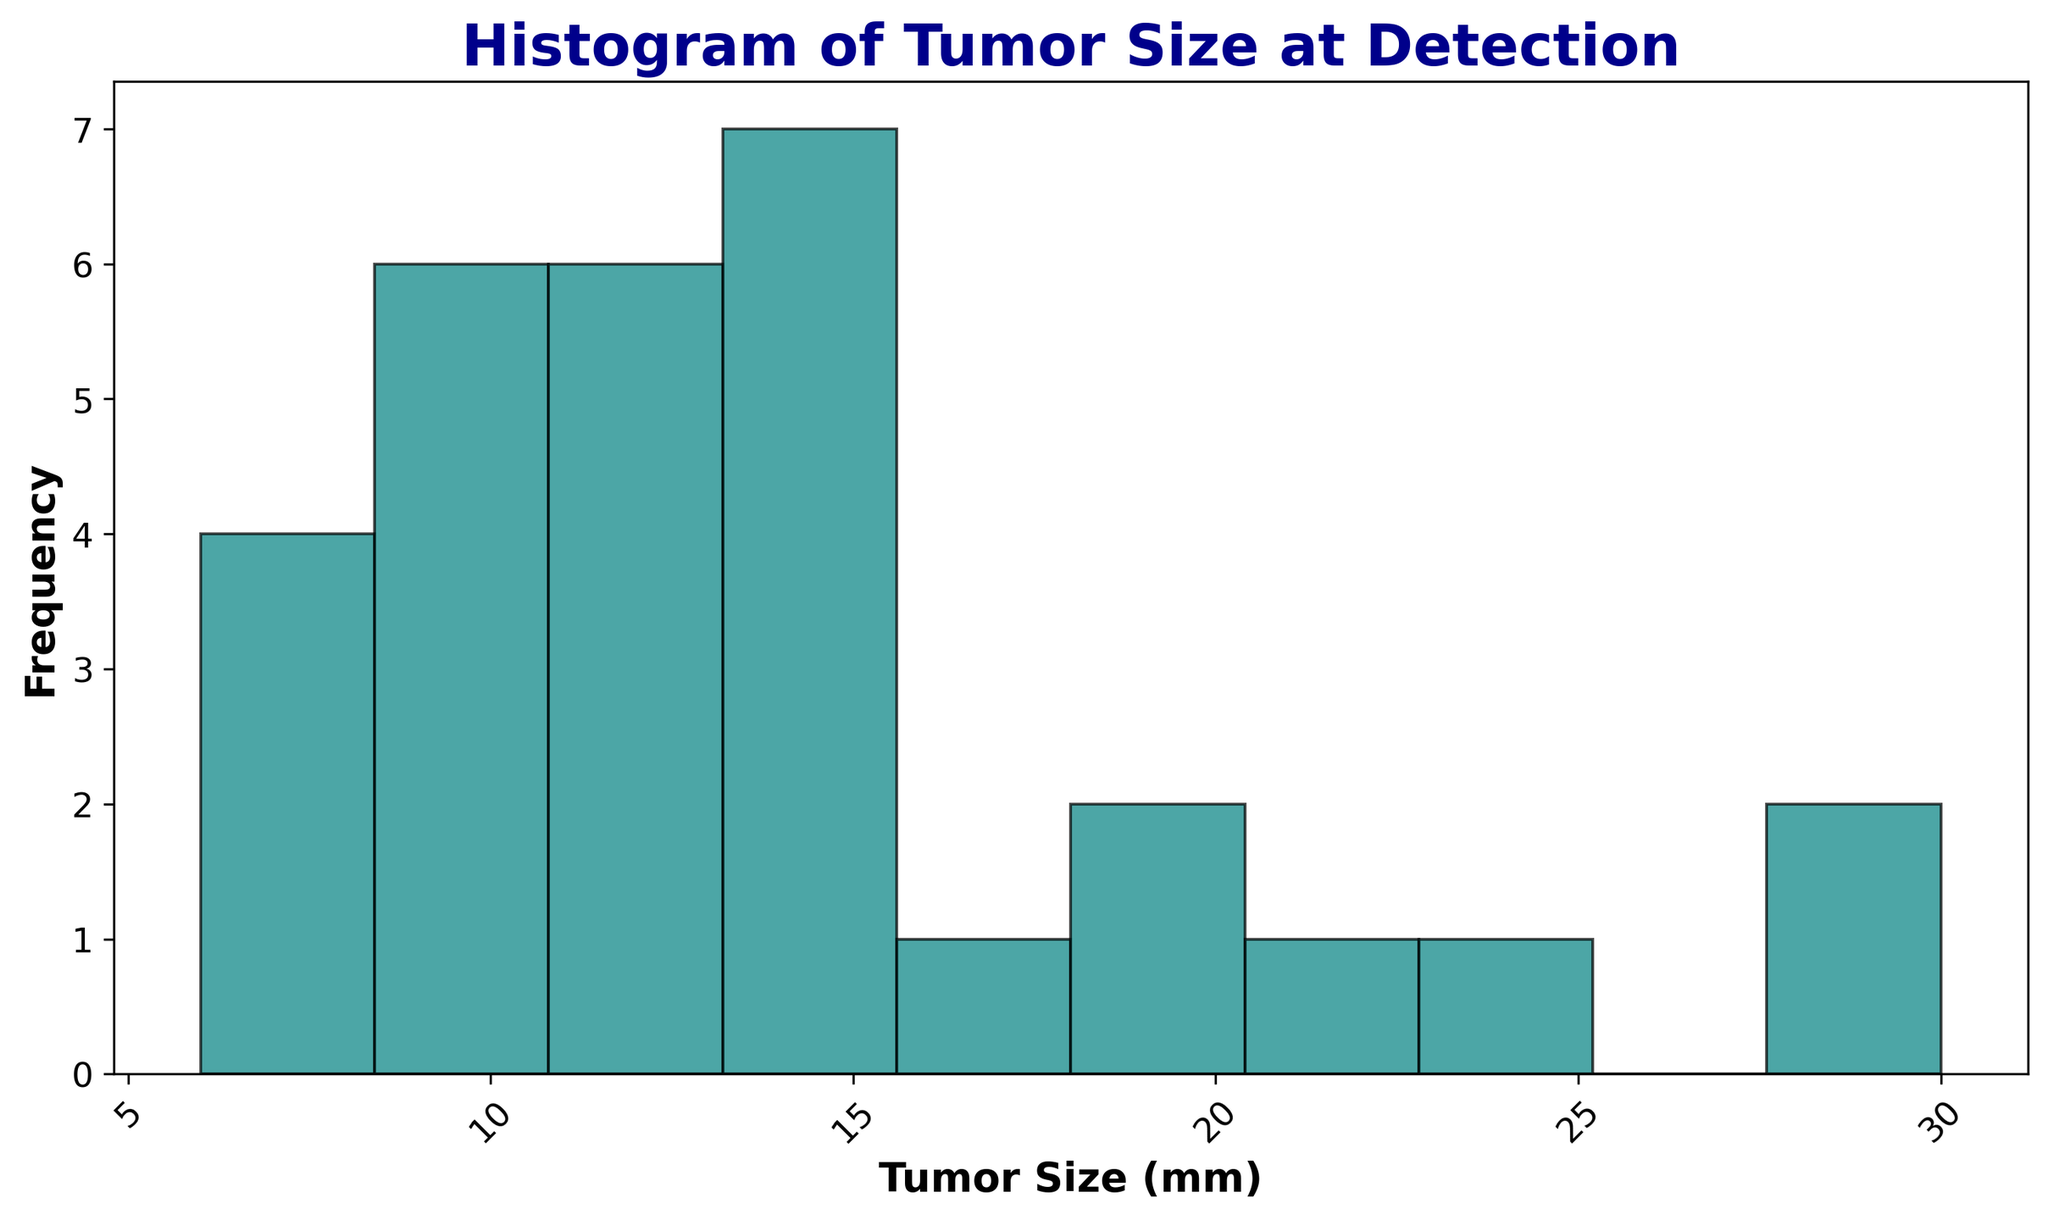What is the most common tumor size at detection? To determine the most common tumor size, we look for the bar with the highest frequency in the histogram. This bar represents the most frequent tumor size at detection.
Answer: 10 mm Which tumor size range has the highest frequency of detection? Look for the bar with the maximum height in the histogram. Identify the bin range that this bar covers.
Answer: 8-10 mm How many tumor sizes were detected within the range of 10 to 15 mm? Count the number of bars that fall within this range and sum their frequencies.
Answer: 8 Is the frequency of tumor sizes larger than 20 mm higher or lower than those smaller than 20 mm? Compare the height of the bars for tumor sizes larger than 20 mm with those smaller than 20 mm. Bars represent frequencies.
Answer: Lower What is the sum of frequencies for tumor sizes less than 10 mm? Identify the bars that represent tumor sizes less than 10 mm, and add their frequencies together.
Answer: 6 How does the frequency of tumor sizes in the range of 15 to 20 mm compare with those in the range of 20 to 25 mm? Look at the bars representing 15-20 mm and 20-25 mm ranges. Compare their heights to determine which has higher frequencies.
Answer: Higher for 15-20 mm What visual attribute helps to distinguish different histograms in this chart? Identify the differences in visual properties used to differentiate the histograms, such as color, edge color, and transparency.
Answer: Color and edge color (teal and black) How many bins are used in the histogram? Count the total number of distinct bars (bins) present in the histogram.
Answer: 10 What is the frequency of the smallest detected tumor size? Locate the bar representing the smallest tumor size, and identify its frequency by the bar's height.
Answer: 1 